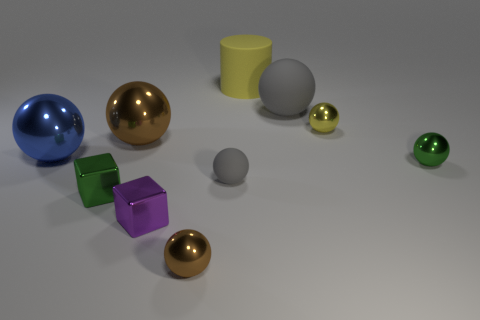Is the small rubber sphere the same color as the big matte ball?
Offer a very short reply. Yes. There is a brown thing that is in front of the large brown shiny ball; what is its shape?
Keep it short and to the point. Sphere. Is the material of the gray thing behind the large blue metal thing the same as the yellow thing that is in front of the big gray matte sphere?
Your answer should be compact. No. Does the green thing that is right of the tiny purple shiny thing have the same shape as the gray rubber object left of the large yellow cylinder?
Provide a succinct answer. Yes. How many other objects are there of the same size as the blue ball?
Offer a very short reply. 3. The cylinder is what size?
Offer a terse response. Large. Is the gray sphere that is behind the tiny gray thing made of the same material as the small purple block?
Make the answer very short. No. There is another small metal object that is the same shape as the purple object; what color is it?
Your response must be concise. Green. There is a big sphere that is right of the purple metallic cube; is it the same color as the tiny rubber object?
Keep it short and to the point. Yes. Are there any brown metallic spheres right of the yellow cylinder?
Give a very brief answer. No. 